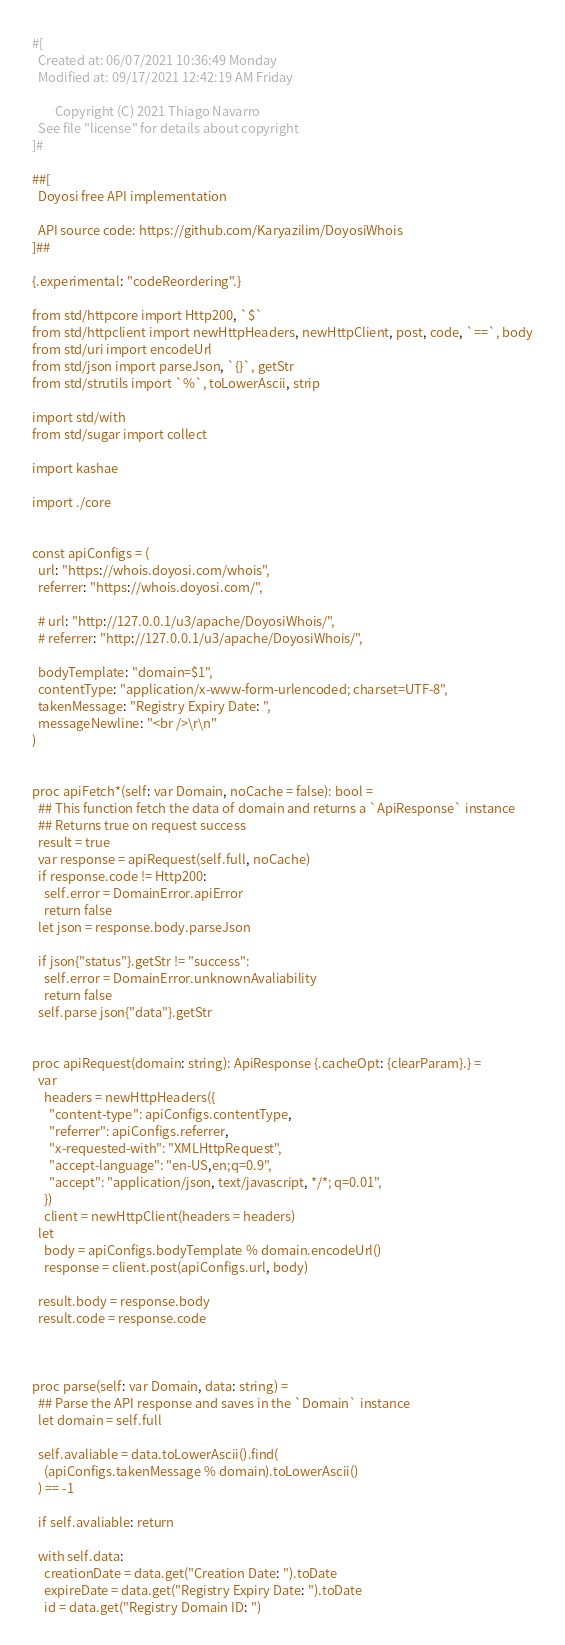<code> <loc_0><loc_0><loc_500><loc_500><_Nim_>#[
  Created at: 06/07/2021 10:36:49 Monday
  Modified at: 09/17/2021 12:42:19 AM Friday

        Copyright (C) 2021 Thiago Navarro
  See file "license" for details about copyright
]#

##[
  Doyosi free API implementation

  API source code: https://github.com/Karyazilim/DoyosiWhois
]##

{.experimental: "codeReordering".}

from std/httpcore import Http200, `$`
from std/httpclient import newHttpHeaders, newHttpClient, post, code, `==`, body
from std/uri import encodeUrl
from std/json import parseJson, `{}`, getStr
from std/strutils import `%`, toLowerAscii, strip

import std/with
from std/sugar import collect

import kashae

import ./core


const apiConfigs = (
  url: "https://whois.doyosi.com/whois",
  referrer: "https://whois.doyosi.com/",

  # url: "http://127.0.0.1/u3/apache/DoyosiWhois/",
  # referrer: "http://127.0.0.1/u3/apache/DoyosiWhois/",

  bodyTemplate: "domain=$1",
  contentType: "application/x-www-form-urlencoded; charset=UTF-8",
  takenMessage: "Registry Expiry Date: ",
  messageNewline: "<br />\r\n"
)


proc apiFetch*(self: var Domain, noCache = false): bool =
  ## This function fetch the data of domain and returns a `ApiResponse` instance
  ## Returns true on request success
  result = true
  var response = apiRequest(self.full, noCache)
  if response.code != Http200:
    self.error = DomainError.apiError
    return false
  let json = response.body.parseJson

  if json{"status"}.getStr != "success":
    self.error = DomainError.unknownAvaliability
    return false
  self.parse json{"data"}.getStr


proc apiRequest(domain: string): ApiResponse {.cacheOpt: {clearParam}.} =
  var
    headers = newHttpHeaders({
      "content-type": apiConfigs.contentType,
      "referrer": apiConfigs.referrer,
      "x-requested-with": "XMLHttpRequest",
      "accept-language": "en-US,en;q=0.9",
      "accept": "application/json, text/javascript, */*; q=0.01",
    })
    client = newHttpClient(headers = headers)
  let
    body = apiConfigs.bodyTemplate % domain.encodeUrl()
    response = client.post(apiConfigs.url, body)

  result.body = response.body
  result.code = response.code



proc parse(self: var Domain, data: string) =
  ## Parse the API response and saves in the `Domain` instance
  let domain = self.full

  self.avaliable = data.toLowerAscii().find(
    (apiConfigs.takenMessage % domain).toLowerAscii()
  ) == -1

  if self.avaliable: return

  with self.data:
    creationDate = data.get("Creation Date: ").toDate
    expireDate = data.get("Registry Expiry Date: ").toDate
    id = data.get("Registry Domain ID: ")</code> 